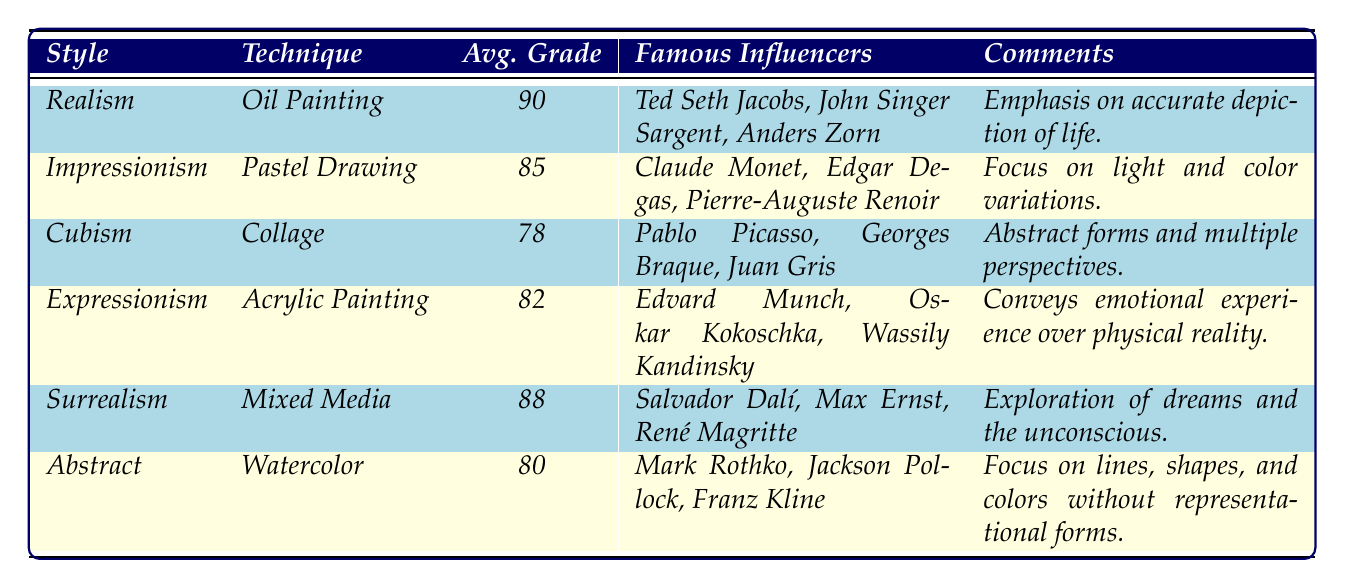What is the average grade for the Realism style? The table shows that the average grade for the Realism style is listed as 90.
Answer: 90 What technique is associated with the highest average grade? By comparing the average grades in the table, Oil Painting under the Realism style has the highest average grade of 90.
Answer: Oil Painting Which famous influencer is associated with Cubism? The table indicates that Pablo Picasso, Georges Braque, and Juan Gris are famous influencers of the Cubism style.
Answer: Pablo Picasso What is the average grade for Abstract art? The table displays that the average grade for Abstract art, which uses Watercolor as a technique, is 80.
Answer: 80 Is the average grade of Surrealism higher than that of Impressionism? The average grade for Surrealism is 88, while that for Impressionism is 85. Since 88 is greater than 85, the statement is true.
Answer: Yes What is the difference in average grades between Expressionism and Cubism? The average grade for Expressionism is 82 and for Cubism, it is 78. The difference is calculated as 82 - 78 = 4.
Answer: 4 List all styles that have an average grade above 85. The table indicates that Realism (90), Surrealism (88), and Impressionism (85) all have average grades above 85.
Answer: Realism, Surrealism, Impressionism Which technique correlates with the lowest average grade? The table shows that Cubism, utilizing Collage, has the lowest average grade of 78.
Answer: Collage What is the average grade for styles with an emotional emphasis? Styles with an emotional emphasis include Expressionism. The average grade is 82. For comparison, Realism does not emphasize emotions. Hence, the average grade is solely from Expressionism.
Answer: 82 Which style's comment emphasizes the exploration of dreams? The comment for Surrealism states it emphasizes the exploration of dreams and the unconscious.
Answer: Surrealism 